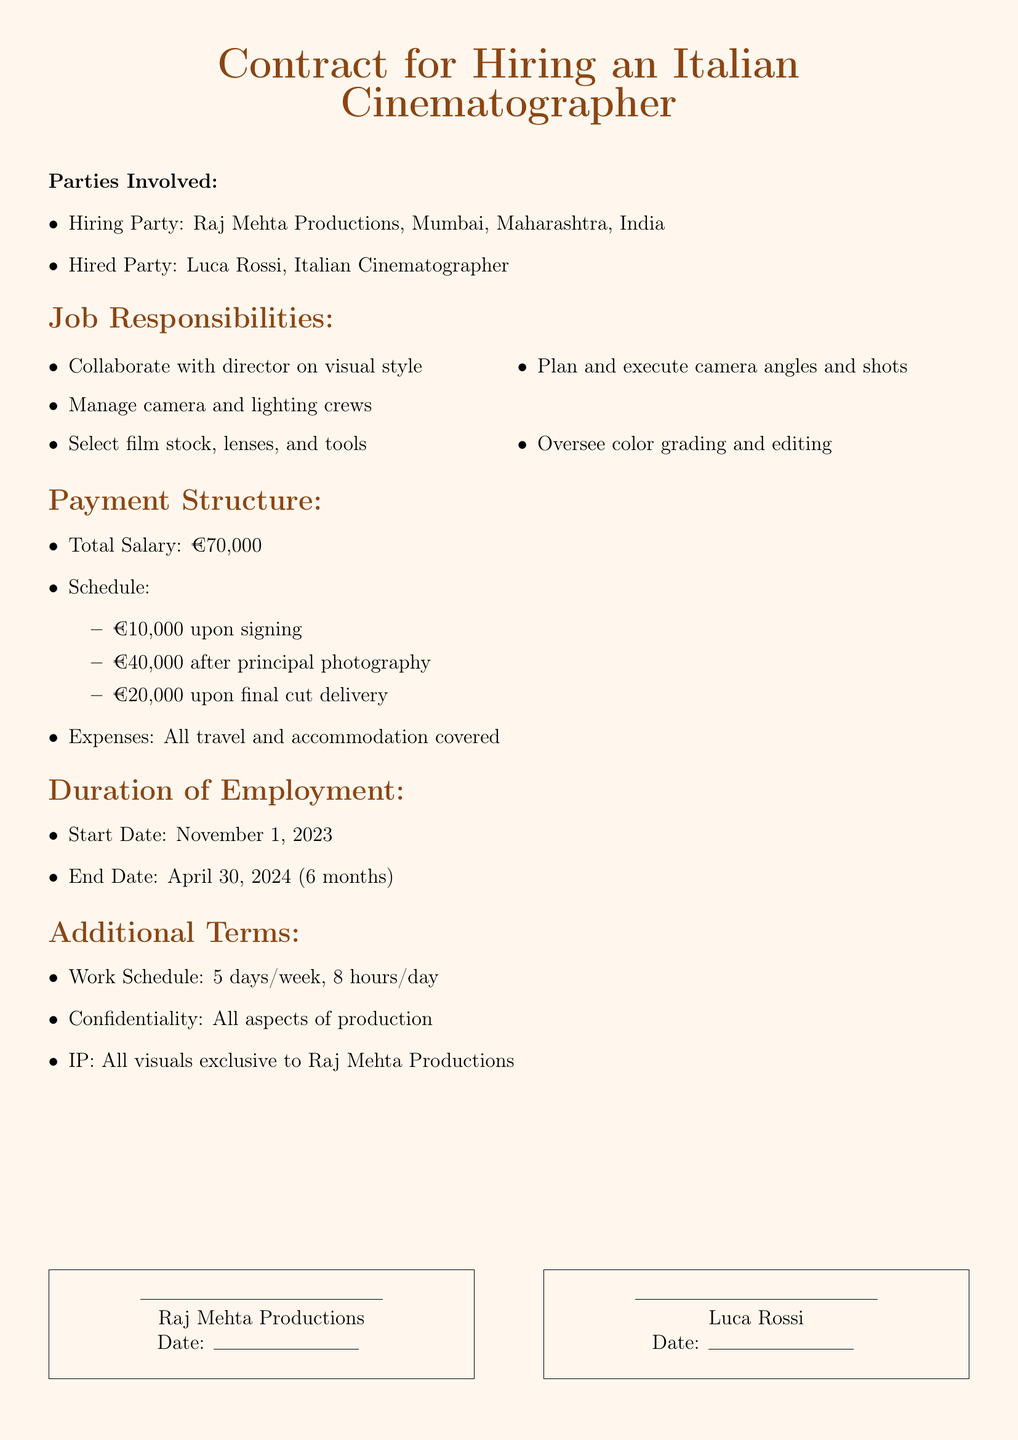What is the total salary for the cinematographer? The total salary is stated clearly in the document as the sum amount.
Answer: €70,000 Who is the hiring party? The hiring party's name and location are provided at the beginning of the document.
Answer: Raj Mehta Productions, Mumbai, Maharashtra, India What is the end date of employment? The end date can be found in the duration section of the document.
Answer: April 30, 2024 How much will be paid upon signing? The payment schedule details the amount due at the signing of the contract.
Answer: €10,000 What are the working hours per day? The work schedule section specifies the hours expected from the hired party.
Answer: 8 hours/day What is the start date of employment? The document explicitly mentions the starting date under the duration of employment.
Answer: November 1, 2023 What does the cinematographer need to oversee? The job responsibilities outline specific tasks expected from the hired party.
Answer: Color grading and editing How many working days per week are expected? The work schedule section indicates the number of days of work in a week.
Answer: 5 days/week What is the hiring party's location? The document specifies the location of the hiring party at the beginning.
Answer: Mumbai, Maharashtra, India 